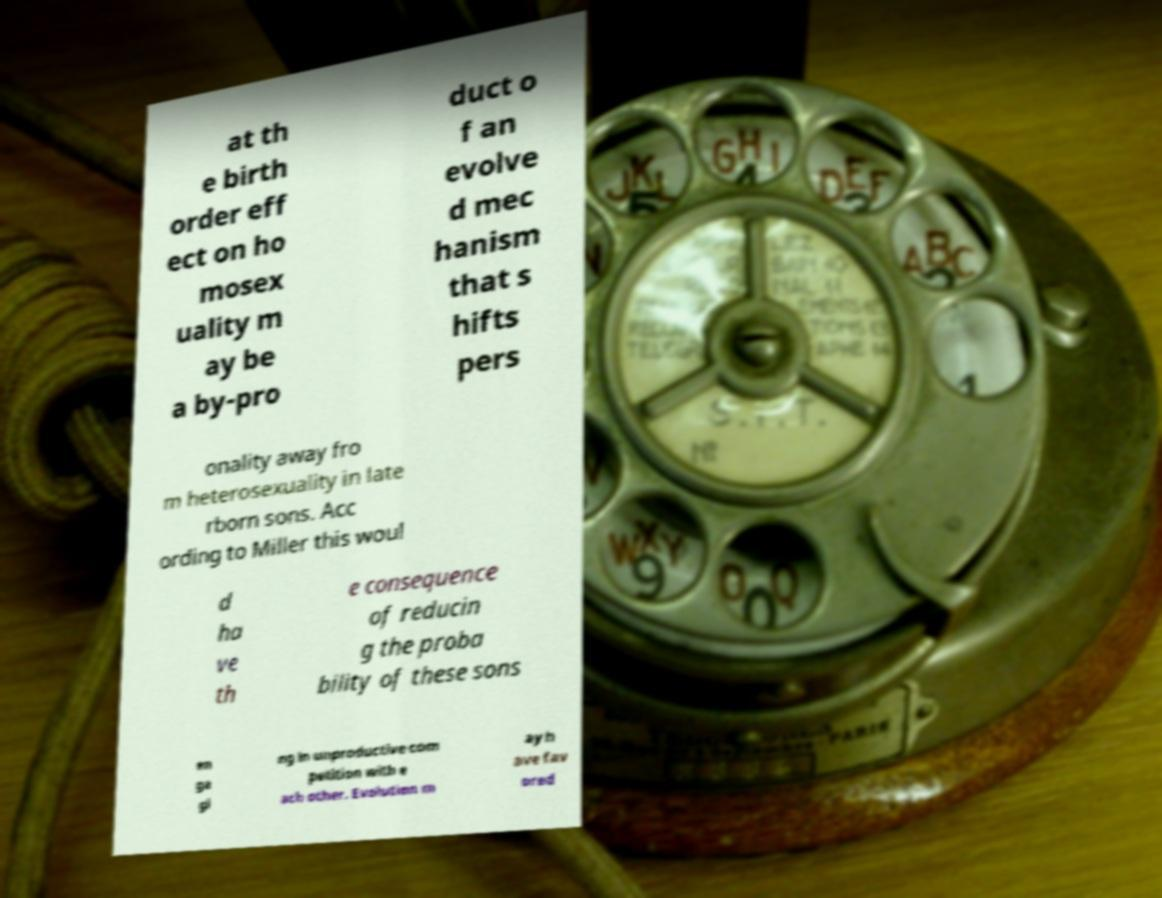I need the written content from this picture converted into text. Can you do that? at th e birth order eff ect on ho mosex uality m ay be a by-pro duct o f an evolve d mec hanism that s hifts pers onality away fro m heterosexuality in late rborn sons. Acc ording to Miller this woul d ha ve th e consequence of reducin g the proba bility of these sons en ga gi ng in unproductive com petition with e ach other. Evolution m ay h ave fav ored 